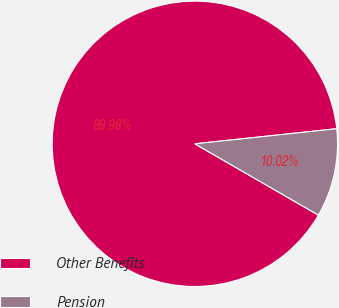Convert chart. <chart><loc_0><loc_0><loc_500><loc_500><pie_chart><fcel>Other Benefits<fcel>Pension<nl><fcel>89.98%<fcel>10.02%<nl></chart> 